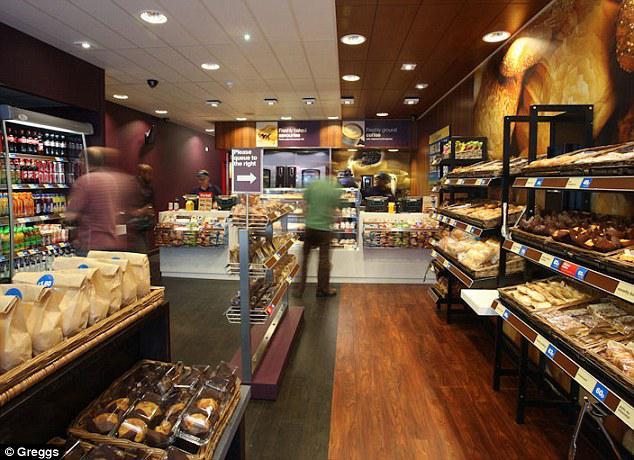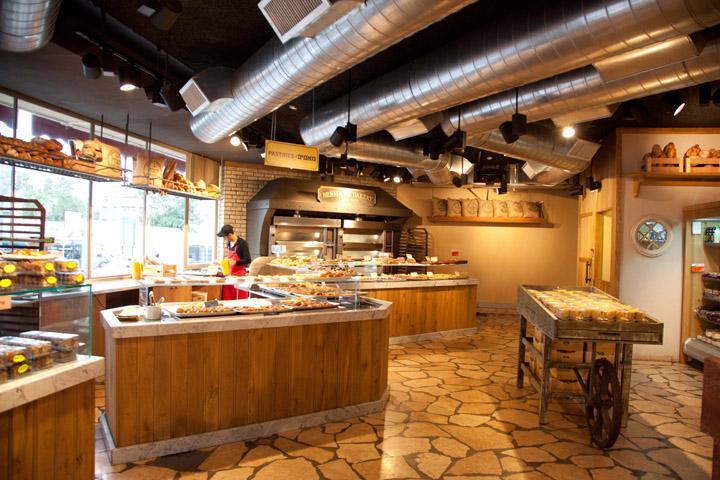The first image is the image on the left, the second image is the image on the right. Examine the images to the left and right. Is the description "An image shows a bakery with a natural tan stone-look floor." accurate? Answer yes or no. Yes. The first image is the image on the left, the second image is the image on the right. Given the left and right images, does the statement "there is exactly one person in the image on the right." hold true? Answer yes or no. Yes. 